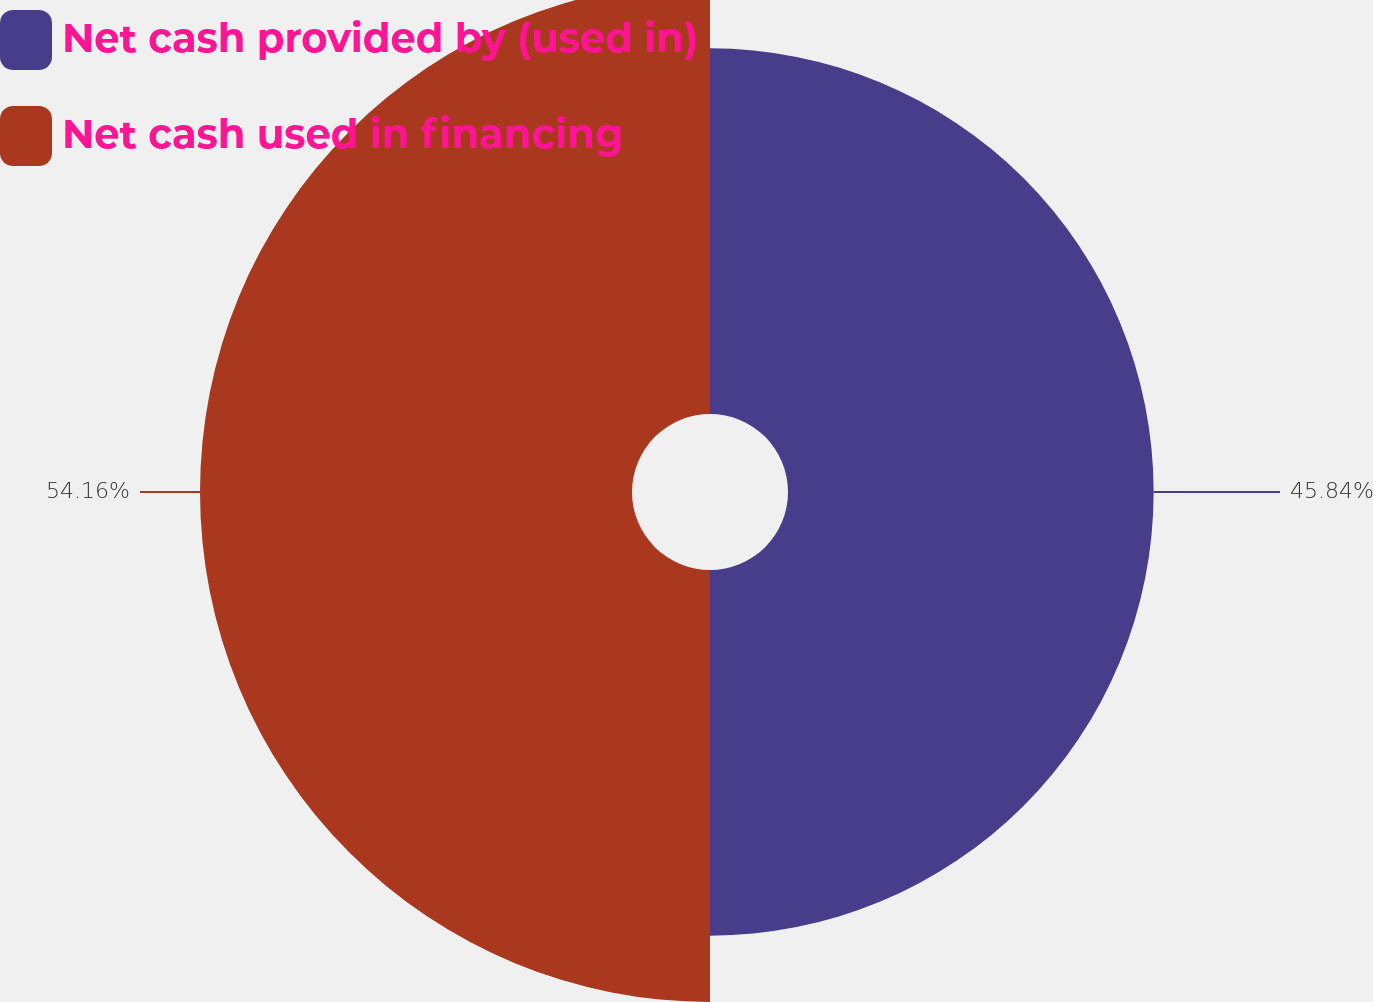Convert chart to OTSL. <chart><loc_0><loc_0><loc_500><loc_500><pie_chart><fcel>Net cash provided by (used in)<fcel>Net cash used in financing<nl><fcel>45.84%<fcel>54.16%<nl></chart> 